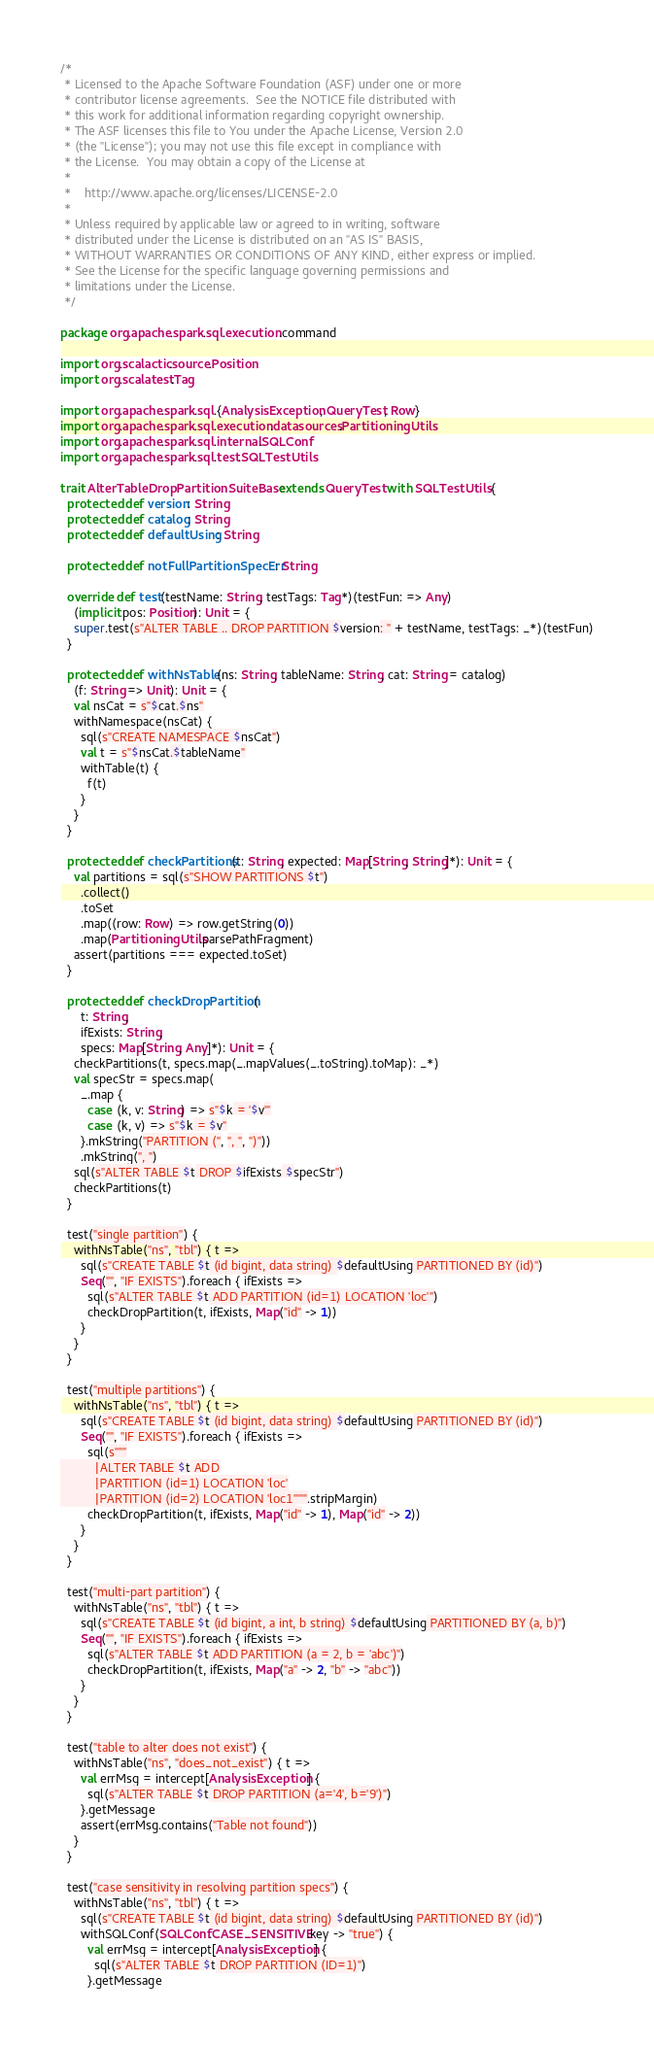<code> <loc_0><loc_0><loc_500><loc_500><_Scala_>/*
 * Licensed to the Apache Software Foundation (ASF) under one or more
 * contributor license agreements.  See the NOTICE file distributed with
 * this work for additional information regarding copyright ownership.
 * The ASF licenses this file to You under the Apache License, Version 2.0
 * (the "License"); you may not use this file except in compliance with
 * the License.  You may obtain a copy of the License at
 *
 *    http://www.apache.org/licenses/LICENSE-2.0
 *
 * Unless required by applicable law or agreed to in writing, software
 * distributed under the License is distributed on an "AS IS" BASIS,
 * WITHOUT WARRANTIES OR CONDITIONS OF ANY KIND, either express or implied.
 * See the License for the specific language governing permissions and
 * limitations under the License.
 */

package org.apache.spark.sql.execution.command

import org.scalactic.source.Position
import org.scalatest.Tag

import org.apache.spark.sql.{AnalysisException, QueryTest, Row}
import org.apache.spark.sql.execution.datasources.PartitioningUtils
import org.apache.spark.sql.internal.SQLConf
import org.apache.spark.sql.test.SQLTestUtils

trait AlterTableDropPartitionSuiteBase  extends QueryTest with SQLTestUtils {
  protected def version: String
  protected def catalog: String
  protected def defaultUsing: String

  protected def notFullPartitionSpecErr: String

  override def test(testName: String, testTags: Tag*)(testFun: => Any)
    (implicit pos: Position): Unit = {
    super.test(s"ALTER TABLE .. DROP PARTITION $version: " + testName, testTags: _*)(testFun)
  }

  protected def withNsTable(ns: String, tableName: String, cat: String = catalog)
    (f: String => Unit): Unit = {
    val nsCat = s"$cat.$ns"
    withNamespace(nsCat) {
      sql(s"CREATE NAMESPACE $nsCat")
      val t = s"$nsCat.$tableName"
      withTable(t) {
        f(t)
      }
    }
  }

  protected def checkPartitions(t: String, expected: Map[String, String]*): Unit = {
    val partitions = sql(s"SHOW PARTITIONS $t")
      .collect()
      .toSet
      .map((row: Row) => row.getString(0))
      .map(PartitioningUtils.parsePathFragment)
    assert(partitions === expected.toSet)
  }

  protected def checkDropPartition(
      t: String,
      ifExists: String,
      specs: Map[String, Any]*): Unit = {
    checkPartitions(t, specs.map(_.mapValues(_.toString).toMap): _*)
    val specStr = specs.map(
      _.map {
        case (k, v: String) => s"$k = '$v'"
        case (k, v) => s"$k = $v"
      }.mkString("PARTITION (", ", ", ")"))
      .mkString(", ")
    sql(s"ALTER TABLE $t DROP $ifExists $specStr")
    checkPartitions(t)
  }

  test("single partition") {
    withNsTable("ns", "tbl") { t =>
      sql(s"CREATE TABLE $t (id bigint, data string) $defaultUsing PARTITIONED BY (id)")
      Seq("", "IF EXISTS").foreach { ifExists =>
        sql(s"ALTER TABLE $t ADD PARTITION (id=1) LOCATION 'loc'")
        checkDropPartition(t, ifExists, Map("id" -> 1))
      }
    }
  }

  test("multiple partitions") {
    withNsTable("ns", "tbl") { t =>
      sql(s"CREATE TABLE $t (id bigint, data string) $defaultUsing PARTITIONED BY (id)")
      Seq("", "IF EXISTS").foreach { ifExists =>
        sql(s"""
          |ALTER TABLE $t ADD
          |PARTITION (id=1) LOCATION 'loc'
          |PARTITION (id=2) LOCATION 'loc1'""".stripMargin)
        checkDropPartition(t, ifExists, Map("id" -> 1), Map("id" -> 2))
      }
    }
  }

  test("multi-part partition") {
    withNsTable("ns", "tbl") { t =>
      sql(s"CREATE TABLE $t (id bigint, a int, b string) $defaultUsing PARTITIONED BY (a, b)")
      Seq("", "IF EXISTS").foreach { ifExists =>
        sql(s"ALTER TABLE $t ADD PARTITION (a = 2, b = 'abc')")
        checkDropPartition(t, ifExists, Map("a" -> 2, "b" -> "abc"))
      }
    }
  }

  test("table to alter does not exist") {
    withNsTable("ns", "does_not_exist") { t =>
      val errMsg = intercept[AnalysisException] {
        sql(s"ALTER TABLE $t DROP PARTITION (a='4', b='9')")
      }.getMessage
      assert(errMsg.contains("Table not found"))
    }
  }

  test("case sensitivity in resolving partition specs") {
    withNsTable("ns", "tbl") { t =>
      sql(s"CREATE TABLE $t (id bigint, data string) $defaultUsing PARTITIONED BY (id)")
      withSQLConf(SQLConf.CASE_SENSITIVE.key -> "true") {
        val errMsg = intercept[AnalysisException] {
          sql(s"ALTER TABLE $t DROP PARTITION (ID=1)")
        }.getMessage</code> 